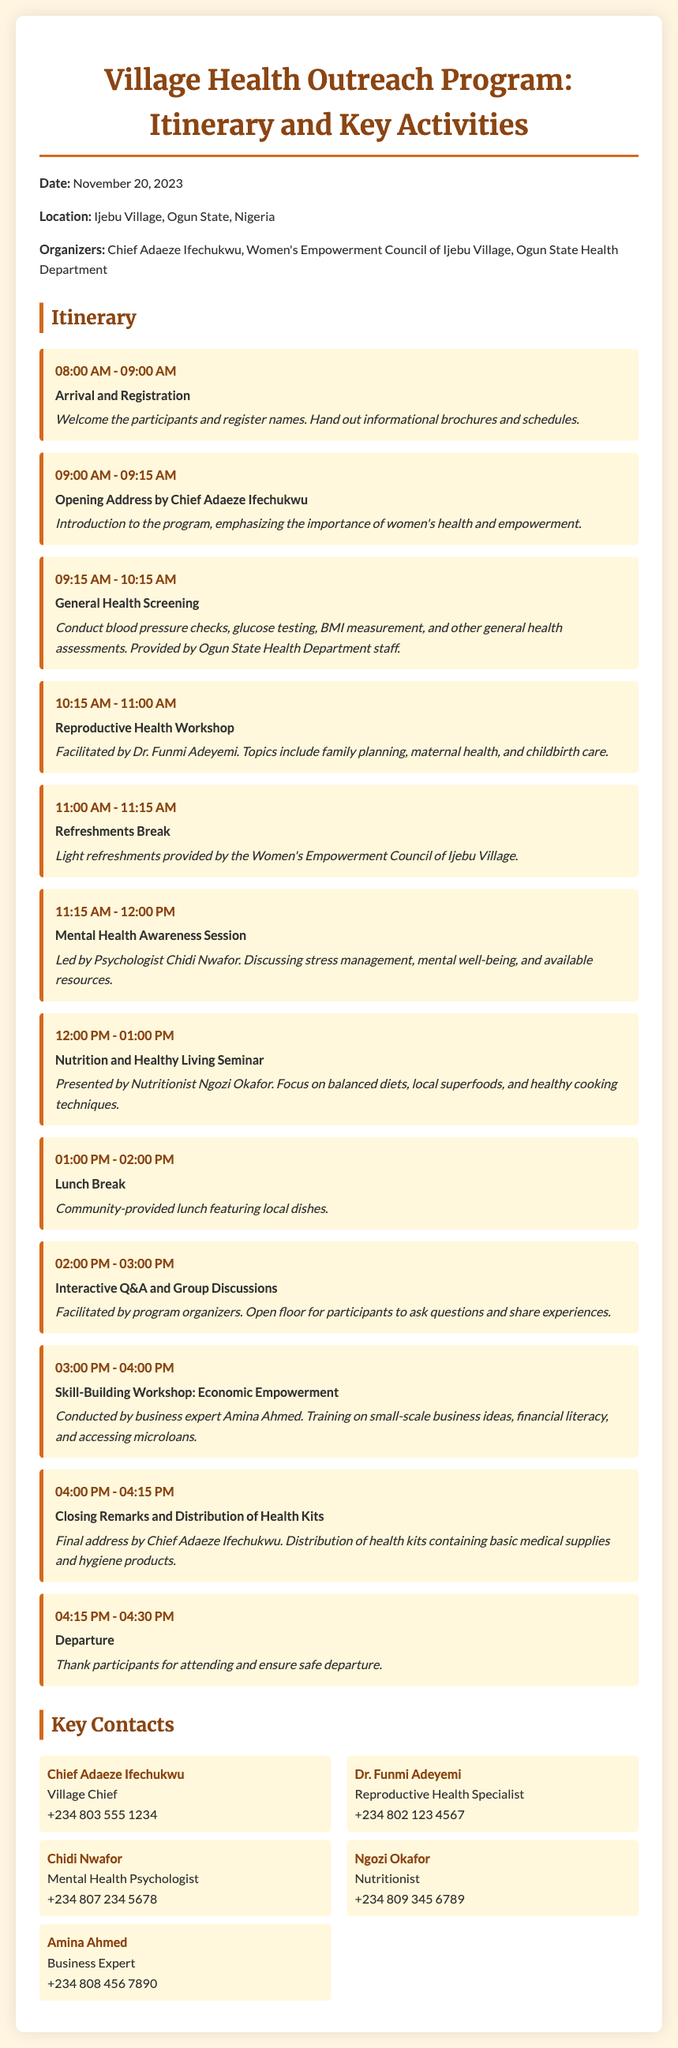What is the date of the program? The date is mentioned at the beginning of the document and is November 20, 2023.
Answer: November 20, 2023 Who is the organizer of the event? The organizer is listed in the document as Chief Adaeze Ifechukwu along with the Women's Empowerment Council of Ijebu Village and the Ogun State Health Department.
Answer: Chief Adaeze Ifechukwu What time does the General Health Screening start? The event layout specifies the time for the General Health Screening starts at 9:15 AM and ends at 10:15 AM.
Answer: 9:15 AM What activity is scheduled after the Refreshments Break? The document indicates that the Mental Health Awareness Session follows the Refreshments Break.
Answer: Mental Health Awareness Session What is the focus of the Nutrition and Healthy Living Seminar? The document states that the seminar focuses on balanced diets, local superfoods, and healthy cooking techniques.
Answer: Balanced diets What is the duration of the opening address? By looking at the itinerary, the opening address is slated for 15 minutes from 9:00 AM to 9:15 AM.
Answer: 15 minutes Who is facilitating the Reproductive Health Workshop? The name of the facilitator for the Reproductive Health Workshop is mentioned in the document as Dr. Funmi Adeyemi.
Answer: Dr. Funmi Adeyemi What time is lunch scheduled? The document indicates that the Lunch Break is scheduled from 1:00 PM to 2:00 PM, making it a one-hour event.
Answer: 1:00 PM - 2:00 PM What will participants receive at the end of the program? The document specifies that participants will receive health kits containing basic medical supplies and hygiene products.
Answer: Health kits 